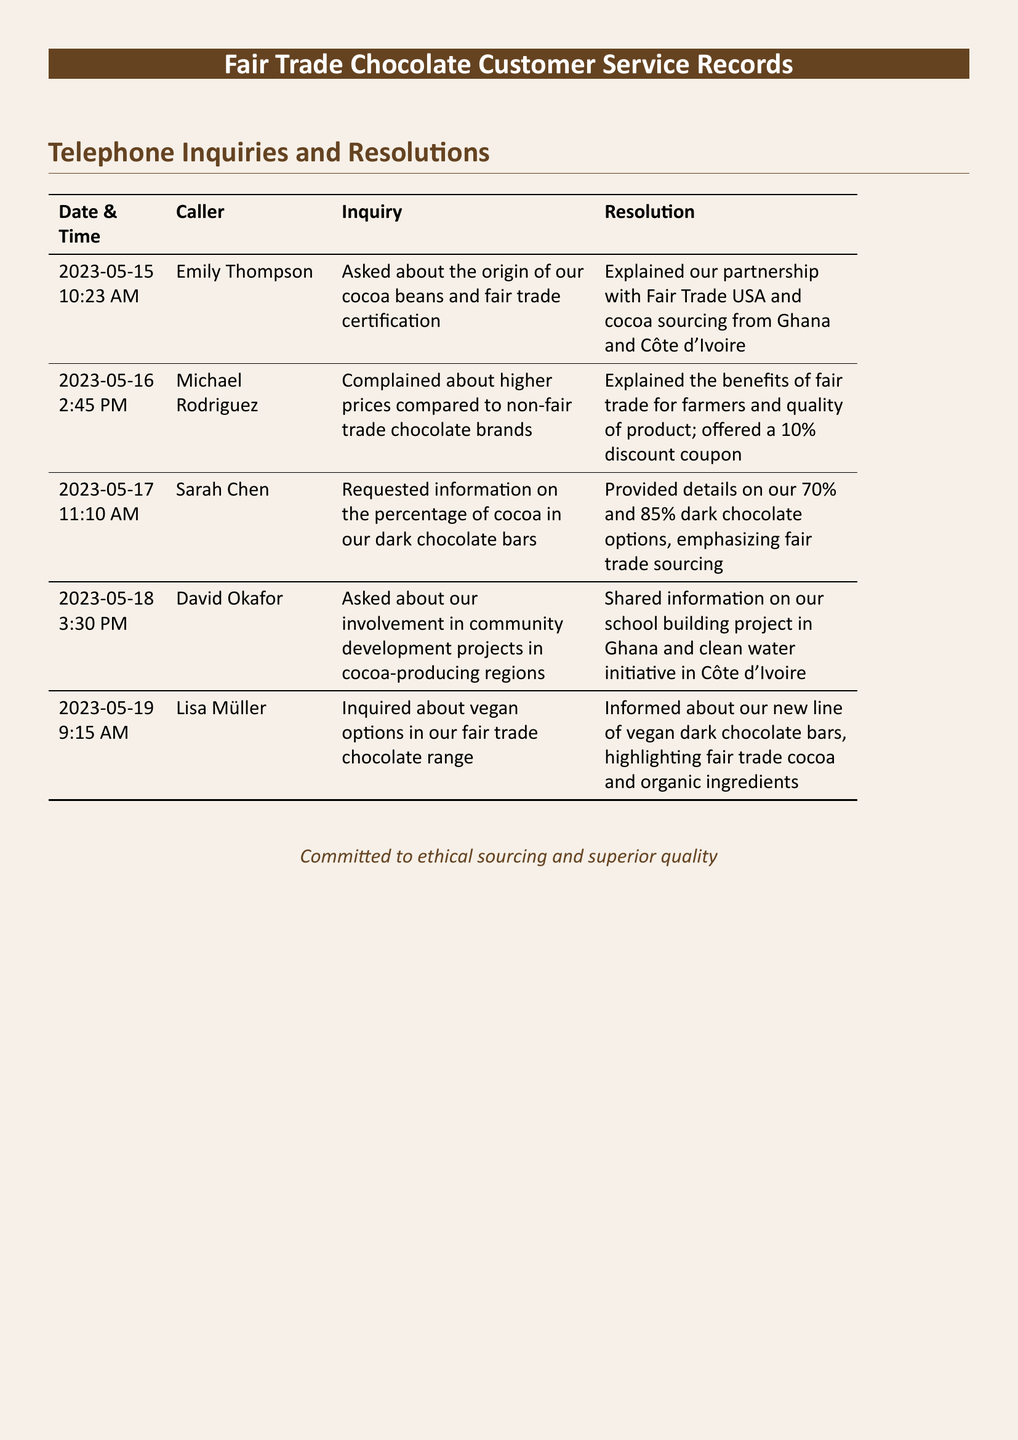What date did Emily Thompson call? The date Emily Thompson called is specified in the document as May 15, 2023.
Answer: May 15, 2023 What was the inquiry of Michael Rodriguez? Michael Rodriguez's inquiry involved a complaint about the higher prices of fair trade chocolate compared to non-fair trade brands.
Answer: Higher prices How much of a discount was offered to Michael Rodriguez? The document states that a 10% discount coupon was offered to Michael Rodriguez.
Answer: 10% Which two countries are mentioned as sources for cocoa beans? The document lists Ghana and Côte d'Ivoire as the two countries from which cocoa is sourced.
Answer: Ghana and Côte d'Ivoire What was discussed in the call with David Okafor? The discussion with David Okafor involved community development projects in cocoa-producing regions.
Answer: Community development projects What percentage of cocoa is featured in the dark chocolate bars? The percentages of cocoa in the dark chocolate bars mentioned are 70% and 85%.
Answer: 70% and 85% What new product line was introduced by Lisa Müller? Lisa Müller inquired about vegan options, indicating a new line of vegan dark chocolate bars was introduced.
Answer: Vegan dark chocolate bars What core value is emphasized in the customer service records? The customer service records emphasize commitment to ethical sourcing and superior quality.
Answer: Ethical sourcing and superior quality 